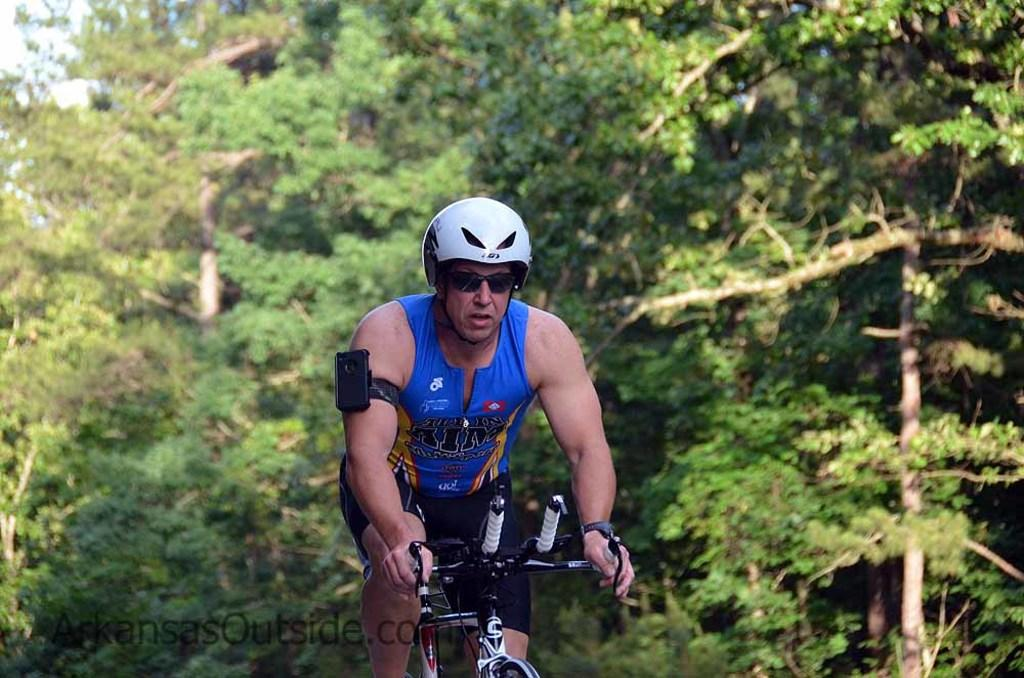Who is the main subject in the image? There is a man in the image. What is the man doing in the image? The man is riding a bicycle. What can be seen in the background of the image? There are trees and the sky visible in the background of the image. Where is the picture of the stick located in the image? There is no picture of a stick present in the image. What type of home is visible in the image? There is no home visible in the image; it features a man riding a bicycle with trees and the sky in the background. 